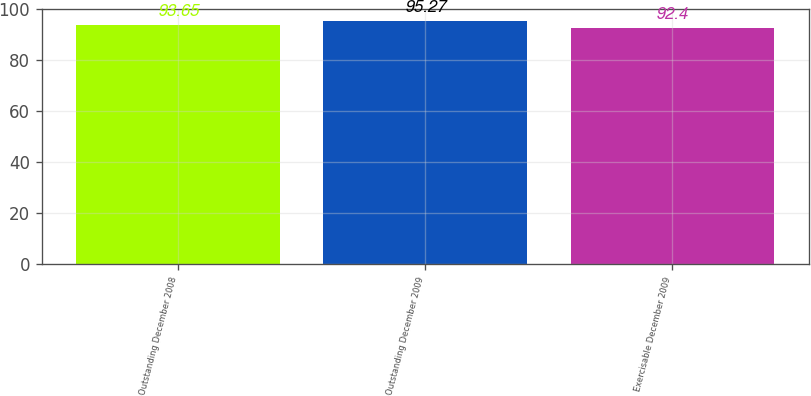<chart> <loc_0><loc_0><loc_500><loc_500><bar_chart><fcel>Outstanding December 2008<fcel>Outstanding December 2009<fcel>Exercisable December 2009<nl><fcel>93.65<fcel>95.27<fcel>92.4<nl></chart> 